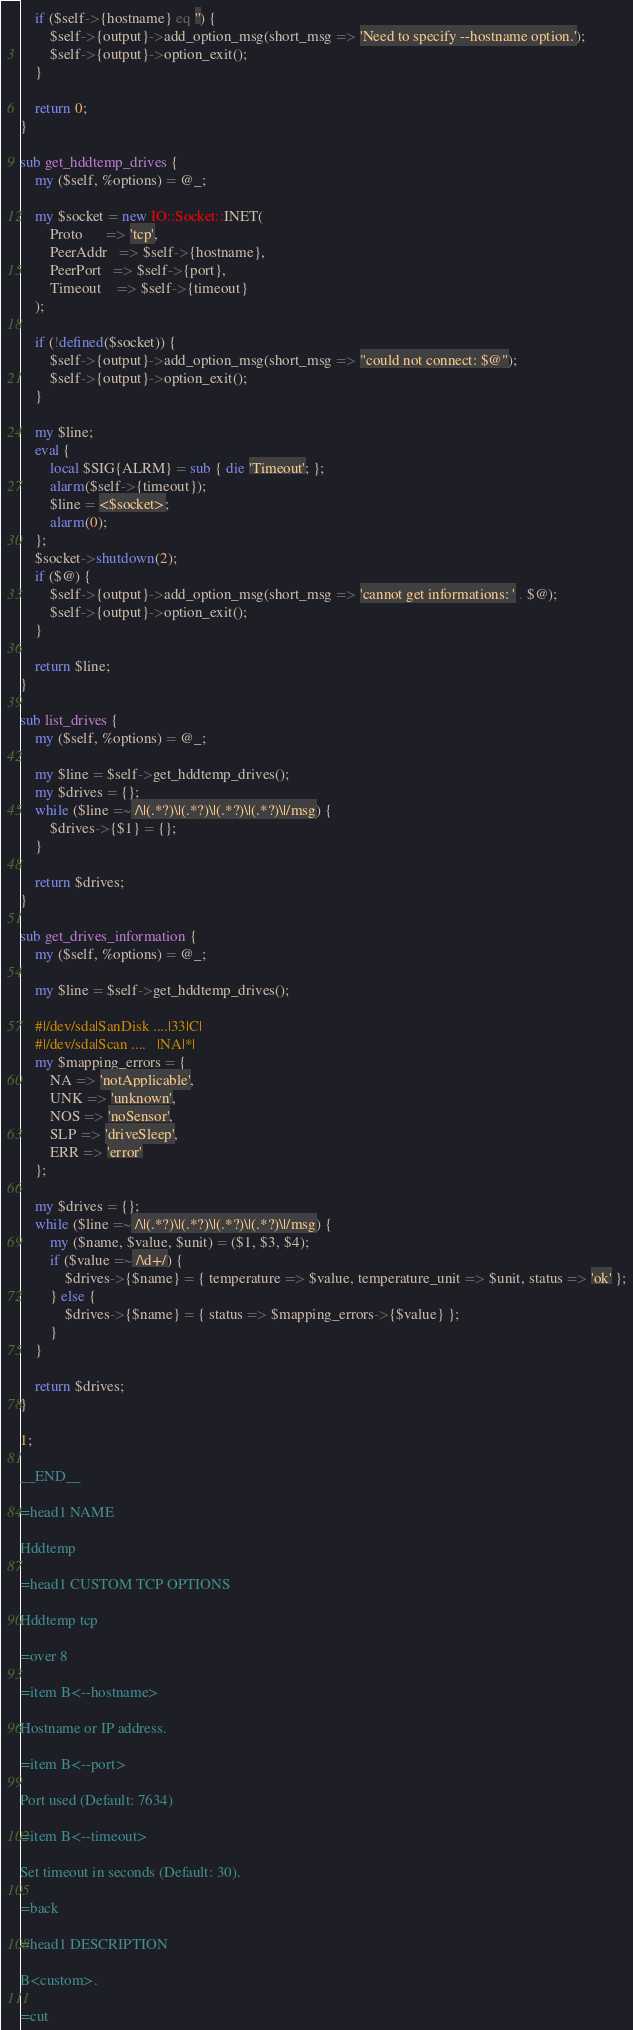Convert code to text. <code><loc_0><loc_0><loc_500><loc_500><_Perl_>
    if ($self->{hostname} eq '') {
        $self->{output}->add_option_msg(short_msg => 'Need to specify --hostname option.');
        $self->{output}->option_exit();
    }

    return 0;
}

sub get_hddtemp_drives {
    my ($self, %options) = @_;

    my $socket = new IO::Socket::INET(
        Proto      => 'tcp', 
        PeerAddr   => $self->{hostname},
        PeerPort   => $self->{port},
        Timeout    => $self->{timeout}
    );
    
    if (!defined($socket)) {
        $self->{output}->add_option_msg(short_msg => "could not connect: $@");
        $self->{output}->option_exit();
    }

    my $line;
    eval {
        local $SIG{ALRM} = sub { die 'Timeout'; };
        alarm($self->{timeout});
        $line = <$socket>;
        alarm(0);
    };
    $socket->shutdown(2);
    if ($@) {
        $self->{output}->add_option_msg(short_msg => 'cannot get informations: ' . $@);
        $self->{output}->option_exit();
    }

    return $line;
}

sub list_drives {
    my ($self, %options) = @_;

    my $line = $self->get_hddtemp_drives();
    my $drives = {};
    while ($line =~ /\|(.*?)\|(.*?)\|(.*?)\|(.*?)\|/msg) {
        $drives->{$1} = {};
    }

    return $drives;
}

sub get_drives_information {
    my ($self, %options) = @_;

    my $line = $self->get_hddtemp_drives();

    #|/dev/sda|SanDisk ....|33|C|
    #|/dev/sda|Scan ....   |NA|*|
    my $mapping_errors = {
        NA => 'notApplicable',
        UNK => 'unknown',
        NOS => 'noSensor',
        SLP => 'driveSleep',
        ERR => 'error'
    };

    my $drives = {};
    while ($line =~ /\|(.*?)\|(.*?)\|(.*?)\|(.*?)\|/msg) {
        my ($name, $value, $unit) = ($1, $3, $4);
        if ($value =~ /\d+/) {
            $drives->{$name} = { temperature => $value, temperature_unit => $unit, status => 'ok' };
        } else {
            $drives->{$name} = { status => $mapping_errors->{$value} };
        }
    }

    return $drives;
}

1;

__END__

=head1 NAME

Hddtemp

=head1 CUSTOM TCP OPTIONS

Hddtemp tcp

=over 8

=item B<--hostname>

Hostname or IP address.

=item B<--port>

Port used (Default: 7634)

=item B<--timeout>

Set timeout in seconds (Default: 30).

=back

=head1 DESCRIPTION

B<custom>.

=cut
</code> 